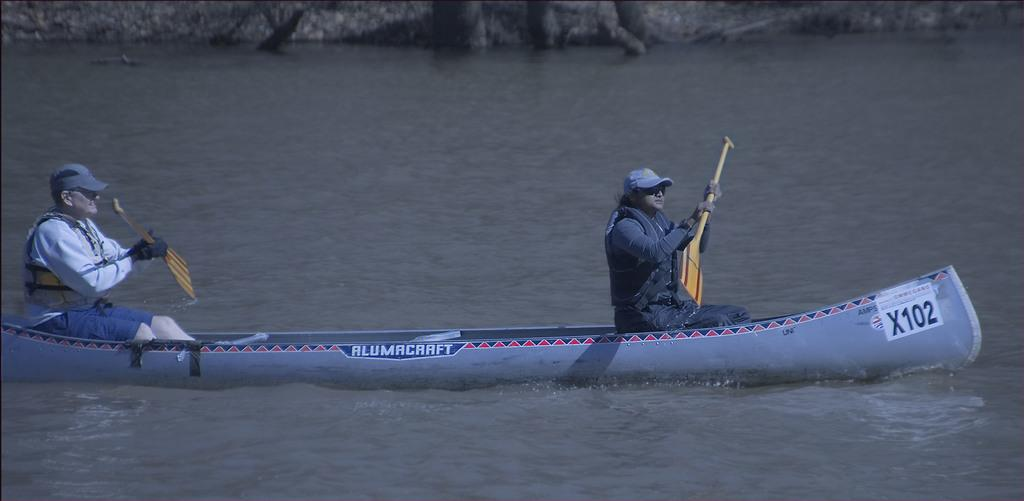How many people are in the image? There are two persons in the image. What are the people wearing? The persons are wearing different color dresses dresses. What are the people holding in their hands? The persons are holding wooden objects. Where are the people sitting? The persons are sitting on a boat. What is the boat's location? The boat is on the water. What type of glue is being used by the persons in the image? There is no glue present in the image; the persons are holding wooden objects. What time of day is it in the image? The provided facts do not mention the time of day, so it cannot be determined from the image. 